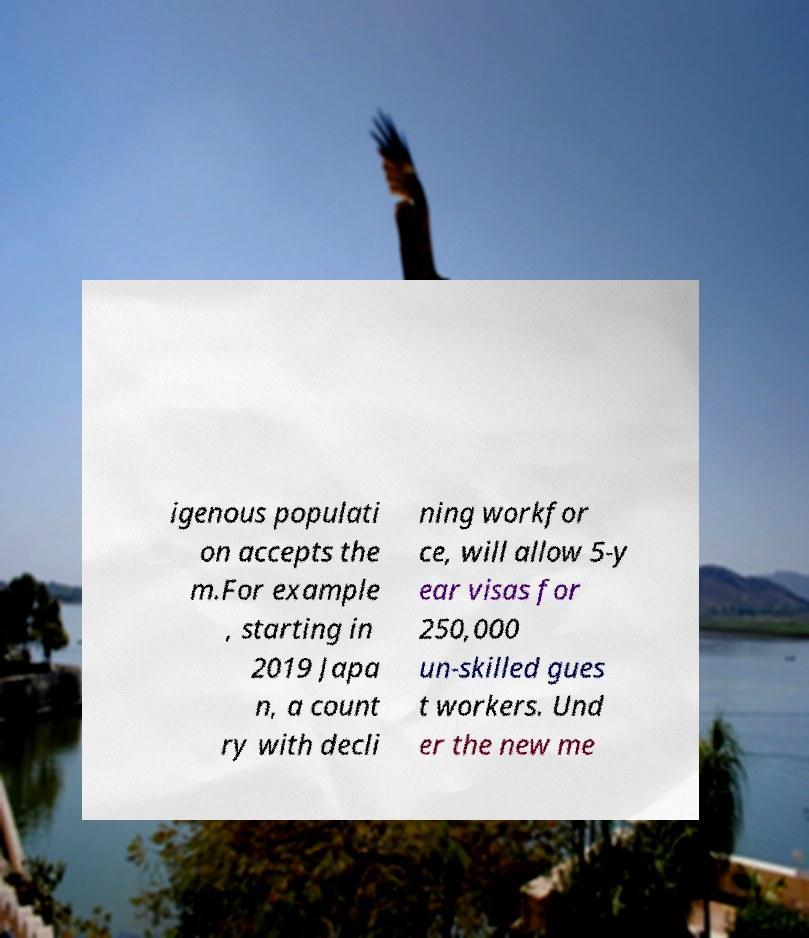Can you accurately transcribe the text from the provided image for me? igenous populati on accepts the m.For example , starting in 2019 Japa n, a count ry with decli ning workfor ce, will allow 5-y ear visas for 250,000 un-skilled gues t workers. Und er the new me 